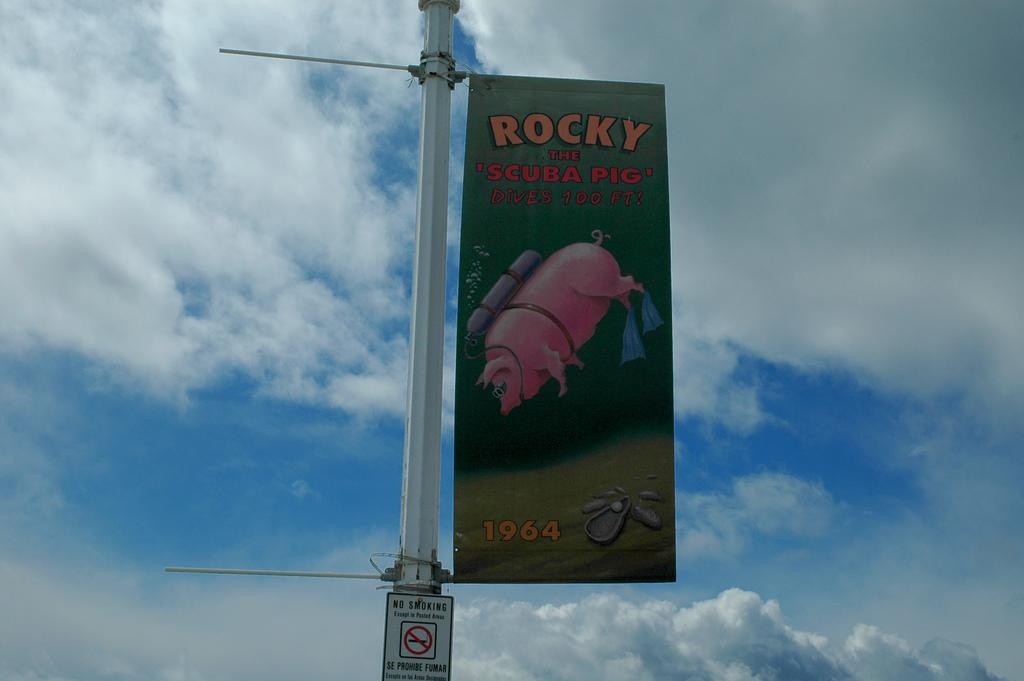<image>
Offer a succinct explanation of the picture presented. A green banner advertises Rocky the scuba pig. 